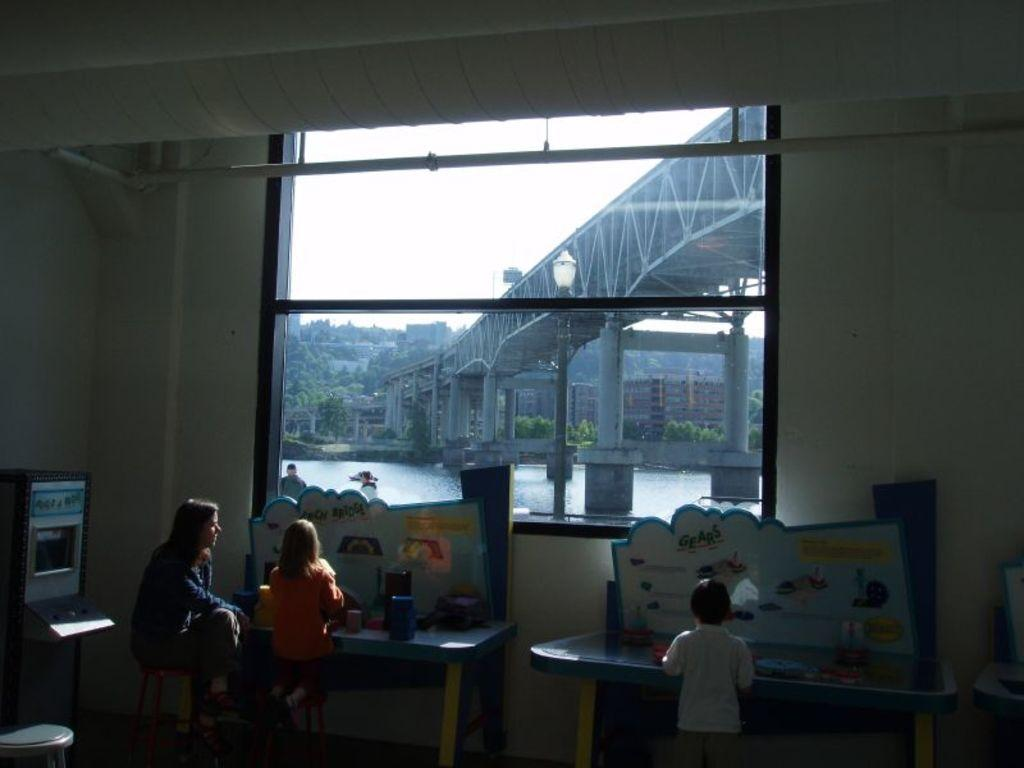How many people can be seen in the image? There are people in the image, but the exact number is not specified. What type of furniture is present in the image? There are tables in the image. What objects are on the walls in the image? There are boards in the image. What architectural feature is present in the image? There is a wall in the image. What can be seen through the window in the image? There is a bridge, water, buildings, trees, and the sky visible through the window. What type of produce is being used as a decoration on the tables in the image? There is no mention of produce or decoration on the tables in the image. What color is the celery that is being served on the plates in the image? There is no celery or plates present in the image. 